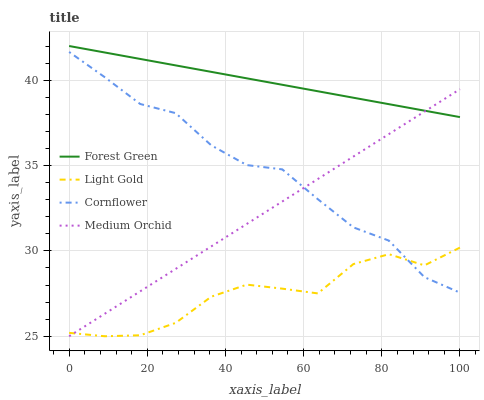Does Light Gold have the minimum area under the curve?
Answer yes or no. Yes. Does Forest Green have the maximum area under the curve?
Answer yes or no. Yes. Does Medium Orchid have the minimum area under the curve?
Answer yes or no. No. Does Medium Orchid have the maximum area under the curve?
Answer yes or no. No. Is Forest Green the smoothest?
Answer yes or no. Yes. Is Light Gold the roughest?
Answer yes or no. Yes. Is Medium Orchid the smoothest?
Answer yes or no. No. Is Medium Orchid the roughest?
Answer yes or no. No. Does Medium Orchid have the lowest value?
Answer yes or no. Yes. Does Forest Green have the lowest value?
Answer yes or no. No. Does Forest Green have the highest value?
Answer yes or no. Yes. Does Medium Orchid have the highest value?
Answer yes or no. No. Is Light Gold less than Forest Green?
Answer yes or no. Yes. Is Forest Green greater than Cornflower?
Answer yes or no. Yes. Does Medium Orchid intersect Cornflower?
Answer yes or no. Yes. Is Medium Orchid less than Cornflower?
Answer yes or no. No. Is Medium Orchid greater than Cornflower?
Answer yes or no. No. Does Light Gold intersect Forest Green?
Answer yes or no. No. 